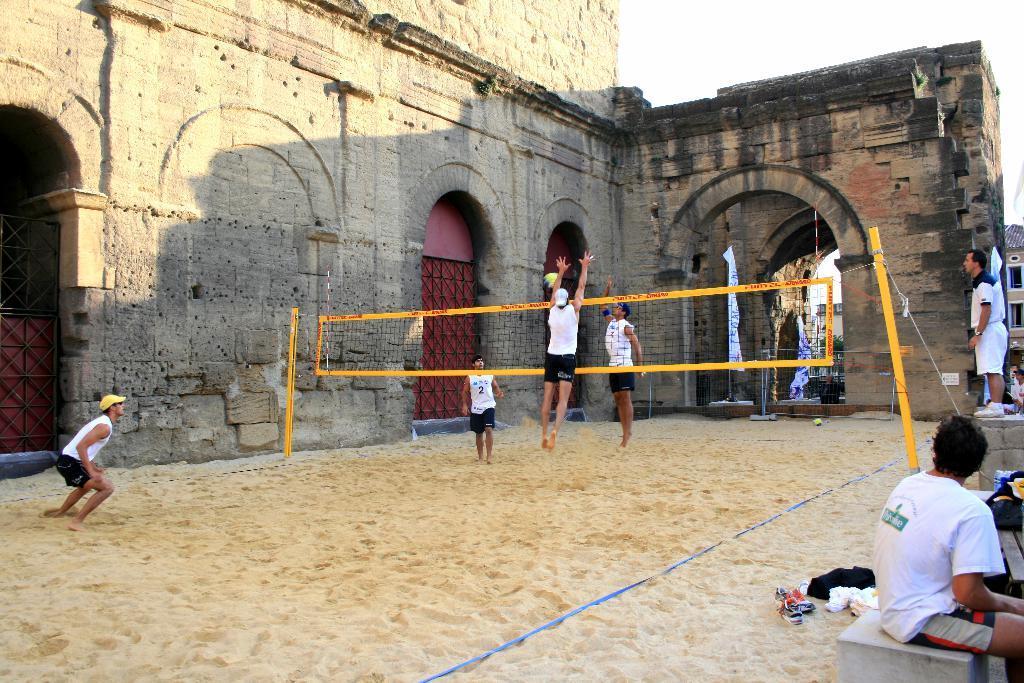Please provide a concise description of this image. In this image in the center there are some people who are playing volleyball, and on the right side there are some persons one person is standing and person is sitting and also there are some clothes. At the bottom there is sand, and in the center there is a net and two poles. In the background there is building. 